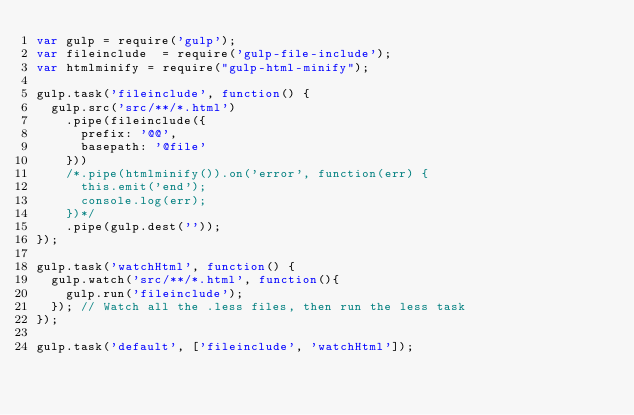<code> <loc_0><loc_0><loc_500><loc_500><_JavaScript_>var gulp = require('gulp');
var fileinclude  = require('gulp-file-include');
var htmlminify = require("gulp-html-minify");

gulp.task('fileinclude', function() {
	gulp.src('src/**/*.html')
		.pipe(fileinclude({
			prefix: '@@',
			basepath: '@file'
		}))
		/*.pipe(htmlminify()).on('error', function(err) {
			this.emit('end');
			console.log(err);
		})*/
		.pipe(gulp.dest(''));
});

gulp.task('watchHtml', function() {
	gulp.watch('src/**/*.html', function(){
		gulp.run('fileinclude');
	}); // Watch all the .less files, then run the less task
});

gulp.task('default', ['fileinclude', 'watchHtml']);</code> 